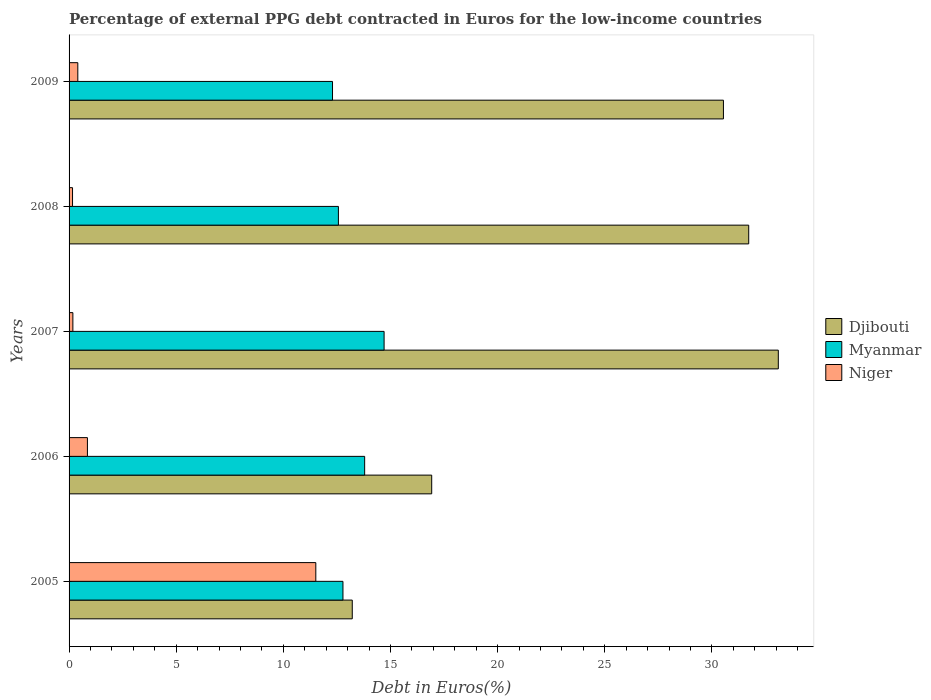How many different coloured bars are there?
Ensure brevity in your answer.  3. How many bars are there on the 2nd tick from the top?
Keep it short and to the point. 3. In how many cases, is the number of bars for a given year not equal to the number of legend labels?
Provide a succinct answer. 0. What is the percentage of external PPG debt contracted in Euros in Niger in 2005?
Keep it short and to the point. 11.52. Across all years, what is the maximum percentage of external PPG debt contracted in Euros in Niger?
Your answer should be compact. 11.52. Across all years, what is the minimum percentage of external PPG debt contracted in Euros in Niger?
Provide a succinct answer. 0.16. What is the total percentage of external PPG debt contracted in Euros in Djibouti in the graph?
Keep it short and to the point. 125.5. What is the difference between the percentage of external PPG debt contracted in Euros in Myanmar in 2005 and that in 2008?
Your answer should be compact. 0.21. What is the difference between the percentage of external PPG debt contracted in Euros in Djibouti in 2006 and the percentage of external PPG debt contracted in Euros in Myanmar in 2005?
Provide a succinct answer. 4.14. What is the average percentage of external PPG debt contracted in Euros in Niger per year?
Your answer should be very brief. 2.62. In the year 2005, what is the difference between the percentage of external PPG debt contracted in Euros in Niger and percentage of external PPG debt contracted in Euros in Myanmar?
Your response must be concise. -1.27. What is the ratio of the percentage of external PPG debt contracted in Euros in Myanmar in 2007 to that in 2009?
Provide a succinct answer. 1.2. Is the percentage of external PPG debt contracted in Euros in Myanmar in 2005 less than that in 2008?
Provide a short and direct response. No. What is the difference between the highest and the second highest percentage of external PPG debt contracted in Euros in Myanmar?
Keep it short and to the point. 0.91. What is the difference between the highest and the lowest percentage of external PPG debt contracted in Euros in Djibouti?
Ensure brevity in your answer.  19.88. In how many years, is the percentage of external PPG debt contracted in Euros in Djibouti greater than the average percentage of external PPG debt contracted in Euros in Djibouti taken over all years?
Offer a very short reply. 3. Is the sum of the percentage of external PPG debt contracted in Euros in Djibouti in 2008 and 2009 greater than the maximum percentage of external PPG debt contracted in Euros in Myanmar across all years?
Keep it short and to the point. Yes. What does the 1st bar from the top in 2006 represents?
Give a very brief answer. Niger. What does the 1st bar from the bottom in 2007 represents?
Ensure brevity in your answer.  Djibouti. Is it the case that in every year, the sum of the percentage of external PPG debt contracted in Euros in Myanmar and percentage of external PPG debt contracted in Euros in Djibouti is greater than the percentage of external PPG debt contracted in Euros in Niger?
Offer a very short reply. Yes. How many bars are there?
Give a very brief answer. 15. Are all the bars in the graph horizontal?
Offer a very short reply. Yes. What is the difference between two consecutive major ticks on the X-axis?
Make the answer very short. 5. Are the values on the major ticks of X-axis written in scientific E-notation?
Provide a succinct answer. No. Does the graph contain any zero values?
Your answer should be compact. No. Does the graph contain grids?
Offer a terse response. No. Where does the legend appear in the graph?
Give a very brief answer. Center right. What is the title of the graph?
Give a very brief answer. Percentage of external PPG debt contracted in Euros for the low-income countries. Does "Congo (Republic)" appear as one of the legend labels in the graph?
Your answer should be very brief. No. What is the label or title of the X-axis?
Give a very brief answer. Debt in Euros(%). What is the label or title of the Y-axis?
Keep it short and to the point. Years. What is the Debt in Euros(%) of Djibouti in 2005?
Keep it short and to the point. 13.22. What is the Debt in Euros(%) in Myanmar in 2005?
Ensure brevity in your answer.  12.78. What is the Debt in Euros(%) in Niger in 2005?
Ensure brevity in your answer.  11.52. What is the Debt in Euros(%) of Djibouti in 2006?
Offer a terse response. 16.92. What is the Debt in Euros(%) of Myanmar in 2006?
Your response must be concise. 13.8. What is the Debt in Euros(%) in Niger in 2006?
Ensure brevity in your answer.  0.86. What is the Debt in Euros(%) in Djibouti in 2007?
Ensure brevity in your answer.  33.1. What is the Debt in Euros(%) in Myanmar in 2007?
Your answer should be very brief. 14.7. What is the Debt in Euros(%) in Niger in 2007?
Your response must be concise. 0.18. What is the Debt in Euros(%) in Djibouti in 2008?
Offer a terse response. 31.72. What is the Debt in Euros(%) of Myanmar in 2008?
Keep it short and to the point. 12.57. What is the Debt in Euros(%) of Niger in 2008?
Your answer should be compact. 0.16. What is the Debt in Euros(%) in Djibouti in 2009?
Your answer should be very brief. 30.54. What is the Debt in Euros(%) in Myanmar in 2009?
Your answer should be compact. 12.3. What is the Debt in Euros(%) in Niger in 2009?
Make the answer very short. 0.41. Across all years, what is the maximum Debt in Euros(%) of Djibouti?
Give a very brief answer. 33.1. Across all years, what is the maximum Debt in Euros(%) of Myanmar?
Offer a terse response. 14.7. Across all years, what is the maximum Debt in Euros(%) in Niger?
Ensure brevity in your answer.  11.52. Across all years, what is the minimum Debt in Euros(%) in Djibouti?
Make the answer very short. 13.22. Across all years, what is the minimum Debt in Euros(%) in Myanmar?
Ensure brevity in your answer.  12.3. Across all years, what is the minimum Debt in Euros(%) in Niger?
Provide a succinct answer. 0.16. What is the total Debt in Euros(%) in Djibouti in the graph?
Make the answer very short. 125.5. What is the total Debt in Euros(%) of Myanmar in the graph?
Your response must be concise. 66.15. What is the total Debt in Euros(%) of Niger in the graph?
Provide a short and direct response. 13.12. What is the difference between the Debt in Euros(%) of Djibouti in 2005 and that in 2006?
Your response must be concise. -3.71. What is the difference between the Debt in Euros(%) in Myanmar in 2005 and that in 2006?
Keep it short and to the point. -1.01. What is the difference between the Debt in Euros(%) of Niger in 2005 and that in 2006?
Your response must be concise. 10.66. What is the difference between the Debt in Euros(%) of Djibouti in 2005 and that in 2007?
Make the answer very short. -19.88. What is the difference between the Debt in Euros(%) of Myanmar in 2005 and that in 2007?
Your answer should be compact. -1.92. What is the difference between the Debt in Euros(%) in Niger in 2005 and that in 2007?
Provide a short and direct response. 11.34. What is the difference between the Debt in Euros(%) of Djibouti in 2005 and that in 2008?
Provide a short and direct response. -18.5. What is the difference between the Debt in Euros(%) of Myanmar in 2005 and that in 2008?
Provide a succinct answer. 0.21. What is the difference between the Debt in Euros(%) in Niger in 2005 and that in 2008?
Your answer should be very brief. 11.35. What is the difference between the Debt in Euros(%) in Djibouti in 2005 and that in 2009?
Provide a succinct answer. -17.32. What is the difference between the Debt in Euros(%) of Myanmar in 2005 and that in 2009?
Give a very brief answer. 0.49. What is the difference between the Debt in Euros(%) of Niger in 2005 and that in 2009?
Offer a terse response. 11.11. What is the difference between the Debt in Euros(%) of Djibouti in 2006 and that in 2007?
Your answer should be very brief. -16.18. What is the difference between the Debt in Euros(%) in Myanmar in 2006 and that in 2007?
Your response must be concise. -0.91. What is the difference between the Debt in Euros(%) of Niger in 2006 and that in 2007?
Provide a succinct answer. 0.68. What is the difference between the Debt in Euros(%) of Djibouti in 2006 and that in 2008?
Offer a very short reply. -14.8. What is the difference between the Debt in Euros(%) of Myanmar in 2006 and that in 2008?
Ensure brevity in your answer.  1.23. What is the difference between the Debt in Euros(%) in Niger in 2006 and that in 2008?
Offer a terse response. 0.69. What is the difference between the Debt in Euros(%) in Djibouti in 2006 and that in 2009?
Ensure brevity in your answer.  -13.62. What is the difference between the Debt in Euros(%) in Myanmar in 2006 and that in 2009?
Give a very brief answer. 1.5. What is the difference between the Debt in Euros(%) in Niger in 2006 and that in 2009?
Make the answer very short. 0.45. What is the difference between the Debt in Euros(%) in Djibouti in 2007 and that in 2008?
Make the answer very short. 1.38. What is the difference between the Debt in Euros(%) of Myanmar in 2007 and that in 2008?
Provide a short and direct response. 2.13. What is the difference between the Debt in Euros(%) in Niger in 2007 and that in 2008?
Give a very brief answer. 0.02. What is the difference between the Debt in Euros(%) of Djibouti in 2007 and that in 2009?
Keep it short and to the point. 2.56. What is the difference between the Debt in Euros(%) of Myanmar in 2007 and that in 2009?
Your response must be concise. 2.41. What is the difference between the Debt in Euros(%) of Niger in 2007 and that in 2009?
Make the answer very short. -0.23. What is the difference between the Debt in Euros(%) of Djibouti in 2008 and that in 2009?
Your answer should be very brief. 1.18. What is the difference between the Debt in Euros(%) in Myanmar in 2008 and that in 2009?
Your answer should be compact. 0.27. What is the difference between the Debt in Euros(%) of Niger in 2008 and that in 2009?
Your response must be concise. -0.25. What is the difference between the Debt in Euros(%) in Djibouti in 2005 and the Debt in Euros(%) in Myanmar in 2006?
Keep it short and to the point. -0.58. What is the difference between the Debt in Euros(%) of Djibouti in 2005 and the Debt in Euros(%) of Niger in 2006?
Offer a very short reply. 12.36. What is the difference between the Debt in Euros(%) of Myanmar in 2005 and the Debt in Euros(%) of Niger in 2006?
Your answer should be very brief. 11.93. What is the difference between the Debt in Euros(%) in Djibouti in 2005 and the Debt in Euros(%) in Myanmar in 2007?
Your answer should be very brief. -1.49. What is the difference between the Debt in Euros(%) of Djibouti in 2005 and the Debt in Euros(%) of Niger in 2007?
Your answer should be very brief. 13.04. What is the difference between the Debt in Euros(%) of Myanmar in 2005 and the Debt in Euros(%) of Niger in 2007?
Offer a very short reply. 12.6. What is the difference between the Debt in Euros(%) in Djibouti in 2005 and the Debt in Euros(%) in Myanmar in 2008?
Offer a very short reply. 0.65. What is the difference between the Debt in Euros(%) in Djibouti in 2005 and the Debt in Euros(%) in Niger in 2008?
Give a very brief answer. 13.06. What is the difference between the Debt in Euros(%) of Myanmar in 2005 and the Debt in Euros(%) of Niger in 2008?
Provide a succinct answer. 12.62. What is the difference between the Debt in Euros(%) in Djibouti in 2005 and the Debt in Euros(%) in Myanmar in 2009?
Offer a very short reply. 0.92. What is the difference between the Debt in Euros(%) of Djibouti in 2005 and the Debt in Euros(%) of Niger in 2009?
Provide a short and direct response. 12.81. What is the difference between the Debt in Euros(%) of Myanmar in 2005 and the Debt in Euros(%) of Niger in 2009?
Provide a succinct answer. 12.37. What is the difference between the Debt in Euros(%) in Djibouti in 2006 and the Debt in Euros(%) in Myanmar in 2007?
Keep it short and to the point. 2.22. What is the difference between the Debt in Euros(%) in Djibouti in 2006 and the Debt in Euros(%) in Niger in 2007?
Make the answer very short. 16.75. What is the difference between the Debt in Euros(%) in Myanmar in 2006 and the Debt in Euros(%) in Niger in 2007?
Keep it short and to the point. 13.62. What is the difference between the Debt in Euros(%) of Djibouti in 2006 and the Debt in Euros(%) of Myanmar in 2008?
Offer a very short reply. 4.35. What is the difference between the Debt in Euros(%) of Djibouti in 2006 and the Debt in Euros(%) of Niger in 2008?
Provide a succinct answer. 16.76. What is the difference between the Debt in Euros(%) in Myanmar in 2006 and the Debt in Euros(%) in Niger in 2008?
Make the answer very short. 13.63. What is the difference between the Debt in Euros(%) of Djibouti in 2006 and the Debt in Euros(%) of Myanmar in 2009?
Your response must be concise. 4.63. What is the difference between the Debt in Euros(%) in Djibouti in 2006 and the Debt in Euros(%) in Niger in 2009?
Your answer should be very brief. 16.52. What is the difference between the Debt in Euros(%) of Myanmar in 2006 and the Debt in Euros(%) of Niger in 2009?
Your answer should be very brief. 13.39. What is the difference between the Debt in Euros(%) in Djibouti in 2007 and the Debt in Euros(%) in Myanmar in 2008?
Your answer should be very brief. 20.53. What is the difference between the Debt in Euros(%) in Djibouti in 2007 and the Debt in Euros(%) in Niger in 2008?
Offer a terse response. 32.94. What is the difference between the Debt in Euros(%) of Myanmar in 2007 and the Debt in Euros(%) of Niger in 2008?
Provide a succinct answer. 14.54. What is the difference between the Debt in Euros(%) of Djibouti in 2007 and the Debt in Euros(%) of Myanmar in 2009?
Provide a succinct answer. 20.81. What is the difference between the Debt in Euros(%) in Djibouti in 2007 and the Debt in Euros(%) in Niger in 2009?
Give a very brief answer. 32.69. What is the difference between the Debt in Euros(%) of Myanmar in 2007 and the Debt in Euros(%) of Niger in 2009?
Your response must be concise. 14.29. What is the difference between the Debt in Euros(%) of Djibouti in 2008 and the Debt in Euros(%) of Myanmar in 2009?
Offer a terse response. 19.42. What is the difference between the Debt in Euros(%) of Djibouti in 2008 and the Debt in Euros(%) of Niger in 2009?
Keep it short and to the point. 31.31. What is the difference between the Debt in Euros(%) in Myanmar in 2008 and the Debt in Euros(%) in Niger in 2009?
Provide a short and direct response. 12.16. What is the average Debt in Euros(%) in Djibouti per year?
Your answer should be very brief. 25.1. What is the average Debt in Euros(%) in Myanmar per year?
Ensure brevity in your answer.  13.23. What is the average Debt in Euros(%) of Niger per year?
Keep it short and to the point. 2.62. In the year 2005, what is the difference between the Debt in Euros(%) in Djibouti and Debt in Euros(%) in Myanmar?
Offer a terse response. 0.43. In the year 2005, what is the difference between the Debt in Euros(%) in Djibouti and Debt in Euros(%) in Niger?
Offer a very short reply. 1.7. In the year 2005, what is the difference between the Debt in Euros(%) in Myanmar and Debt in Euros(%) in Niger?
Provide a short and direct response. 1.27. In the year 2006, what is the difference between the Debt in Euros(%) in Djibouti and Debt in Euros(%) in Myanmar?
Your answer should be compact. 3.13. In the year 2006, what is the difference between the Debt in Euros(%) in Djibouti and Debt in Euros(%) in Niger?
Provide a short and direct response. 16.07. In the year 2006, what is the difference between the Debt in Euros(%) in Myanmar and Debt in Euros(%) in Niger?
Offer a terse response. 12.94. In the year 2007, what is the difference between the Debt in Euros(%) in Djibouti and Debt in Euros(%) in Myanmar?
Provide a short and direct response. 18.4. In the year 2007, what is the difference between the Debt in Euros(%) in Djibouti and Debt in Euros(%) in Niger?
Ensure brevity in your answer.  32.92. In the year 2007, what is the difference between the Debt in Euros(%) of Myanmar and Debt in Euros(%) of Niger?
Your response must be concise. 14.52. In the year 2008, what is the difference between the Debt in Euros(%) of Djibouti and Debt in Euros(%) of Myanmar?
Your answer should be very brief. 19.15. In the year 2008, what is the difference between the Debt in Euros(%) in Djibouti and Debt in Euros(%) in Niger?
Your answer should be compact. 31.56. In the year 2008, what is the difference between the Debt in Euros(%) in Myanmar and Debt in Euros(%) in Niger?
Offer a very short reply. 12.41. In the year 2009, what is the difference between the Debt in Euros(%) of Djibouti and Debt in Euros(%) of Myanmar?
Give a very brief answer. 18.24. In the year 2009, what is the difference between the Debt in Euros(%) in Djibouti and Debt in Euros(%) in Niger?
Give a very brief answer. 30.13. In the year 2009, what is the difference between the Debt in Euros(%) of Myanmar and Debt in Euros(%) of Niger?
Offer a terse response. 11.89. What is the ratio of the Debt in Euros(%) in Djibouti in 2005 to that in 2006?
Your answer should be compact. 0.78. What is the ratio of the Debt in Euros(%) in Myanmar in 2005 to that in 2006?
Make the answer very short. 0.93. What is the ratio of the Debt in Euros(%) in Niger in 2005 to that in 2006?
Your response must be concise. 13.45. What is the ratio of the Debt in Euros(%) in Djibouti in 2005 to that in 2007?
Give a very brief answer. 0.4. What is the ratio of the Debt in Euros(%) in Myanmar in 2005 to that in 2007?
Offer a very short reply. 0.87. What is the ratio of the Debt in Euros(%) in Niger in 2005 to that in 2007?
Your answer should be compact. 64.77. What is the ratio of the Debt in Euros(%) in Djibouti in 2005 to that in 2008?
Keep it short and to the point. 0.42. What is the ratio of the Debt in Euros(%) in Myanmar in 2005 to that in 2008?
Provide a succinct answer. 1.02. What is the ratio of the Debt in Euros(%) of Niger in 2005 to that in 2008?
Your answer should be compact. 71.22. What is the ratio of the Debt in Euros(%) in Djibouti in 2005 to that in 2009?
Your response must be concise. 0.43. What is the ratio of the Debt in Euros(%) of Myanmar in 2005 to that in 2009?
Your answer should be compact. 1.04. What is the ratio of the Debt in Euros(%) of Niger in 2005 to that in 2009?
Offer a very short reply. 28.24. What is the ratio of the Debt in Euros(%) in Djibouti in 2006 to that in 2007?
Offer a terse response. 0.51. What is the ratio of the Debt in Euros(%) in Myanmar in 2006 to that in 2007?
Your response must be concise. 0.94. What is the ratio of the Debt in Euros(%) in Niger in 2006 to that in 2007?
Your response must be concise. 4.82. What is the ratio of the Debt in Euros(%) of Djibouti in 2006 to that in 2008?
Ensure brevity in your answer.  0.53. What is the ratio of the Debt in Euros(%) in Myanmar in 2006 to that in 2008?
Keep it short and to the point. 1.1. What is the ratio of the Debt in Euros(%) of Niger in 2006 to that in 2008?
Provide a succinct answer. 5.3. What is the ratio of the Debt in Euros(%) in Djibouti in 2006 to that in 2009?
Your response must be concise. 0.55. What is the ratio of the Debt in Euros(%) of Myanmar in 2006 to that in 2009?
Offer a very short reply. 1.12. What is the ratio of the Debt in Euros(%) in Niger in 2006 to that in 2009?
Keep it short and to the point. 2.1. What is the ratio of the Debt in Euros(%) of Djibouti in 2007 to that in 2008?
Your answer should be very brief. 1.04. What is the ratio of the Debt in Euros(%) in Myanmar in 2007 to that in 2008?
Your answer should be very brief. 1.17. What is the ratio of the Debt in Euros(%) in Niger in 2007 to that in 2008?
Ensure brevity in your answer.  1.1. What is the ratio of the Debt in Euros(%) in Djibouti in 2007 to that in 2009?
Ensure brevity in your answer.  1.08. What is the ratio of the Debt in Euros(%) in Myanmar in 2007 to that in 2009?
Offer a very short reply. 1.2. What is the ratio of the Debt in Euros(%) in Niger in 2007 to that in 2009?
Your response must be concise. 0.44. What is the ratio of the Debt in Euros(%) of Djibouti in 2008 to that in 2009?
Ensure brevity in your answer.  1.04. What is the ratio of the Debt in Euros(%) in Myanmar in 2008 to that in 2009?
Your answer should be very brief. 1.02. What is the ratio of the Debt in Euros(%) in Niger in 2008 to that in 2009?
Provide a succinct answer. 0.4. What is the difference between the highest and the second highest Debt in Euros(%) of Djibouti?
Your answer should be very brief. 1.38. What is the difference between the highest and the second highest Debt in Euros(%) in Myanmar?
Give a very brief answer. 0.91. What is the difference between the highest and the second highest Debt in Euros(%) in Niger?
Ensure brevity in your answer.  10.66. What is the difference between the highest and the lowest Debt in Euros(%) in Djibouti?
Your response must be concise. 19.88. What is the difference between the highest and the lowest Debt in Euros(%) of Myanmar?
Provide a short and direct response. 2.41. What is the difference between the highest and the lowest Debt in Euros(%) in Niger?
Keep it short and to the point. 11.35. 